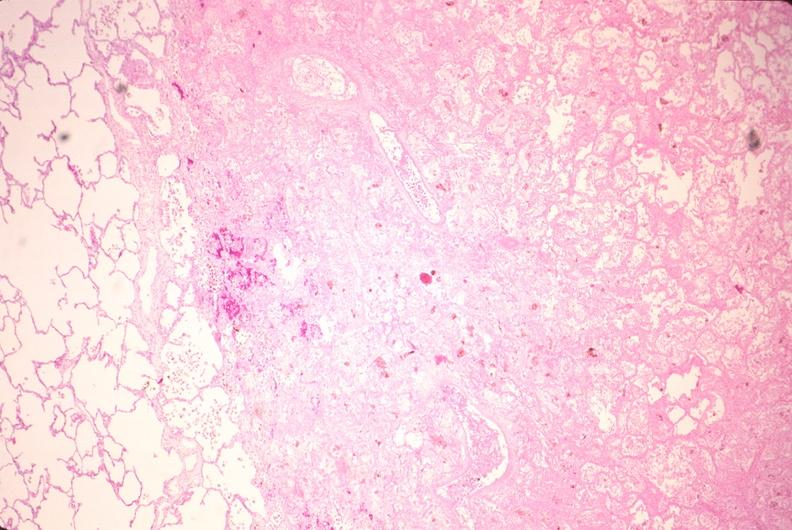where is this?
Answer the question using a single word or phrase. Lung 